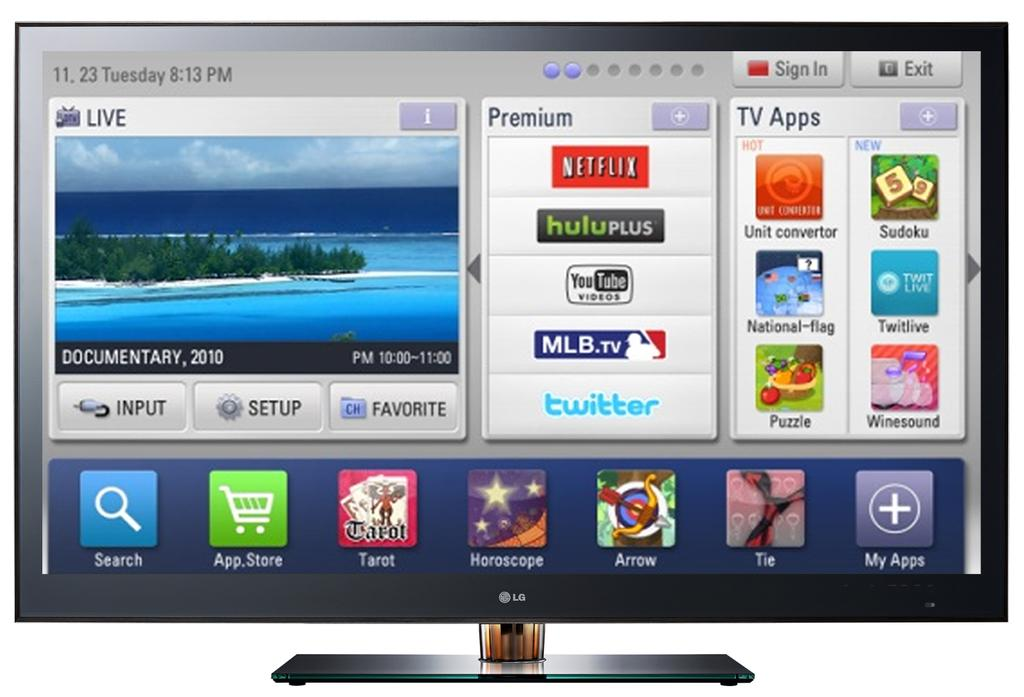<image>
Share a concise interpretation of the image provided. a computer desktop with icons for netflix hulu, twitter and mlb tv. 